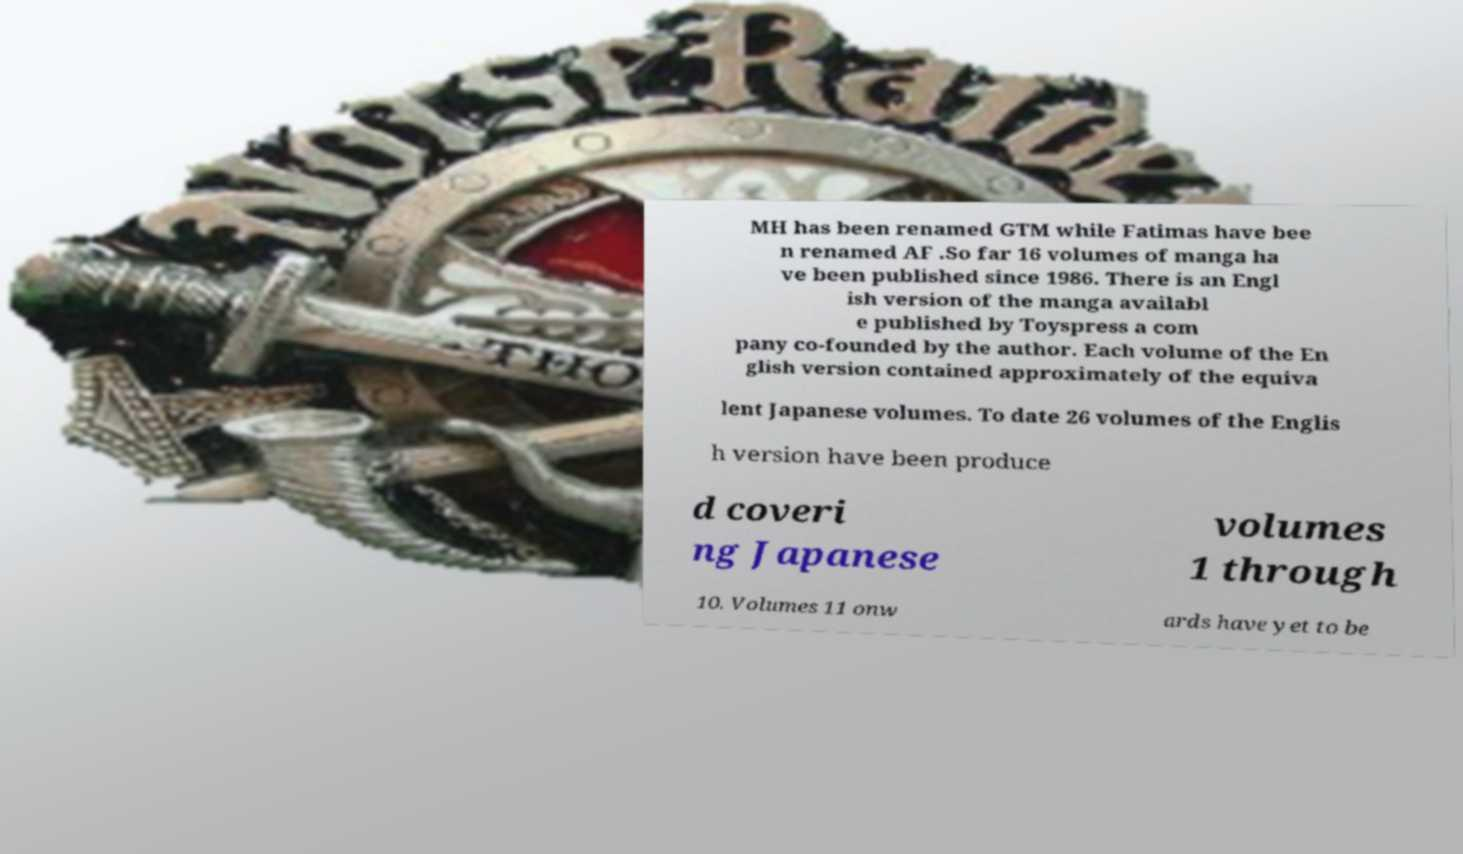For documentation purposes, I need the text within this image transcribed. Could you provide that? MH has been renamed GTM while Fatimas have bee n renamed AF .So far 16 volumes of manga ha ve been published since 1986. There is an Engl ish version of the manga availabl e published by Toyspress a com pany co-founded by the author. Each volume of the En glish version contained approximately of the equiva lent Japanese volumes. To date 26 volumes of the Englis h version have been produce d coveri ng Japanese volumes 1 through 10. Volumes 11 onw ards have yet to be 